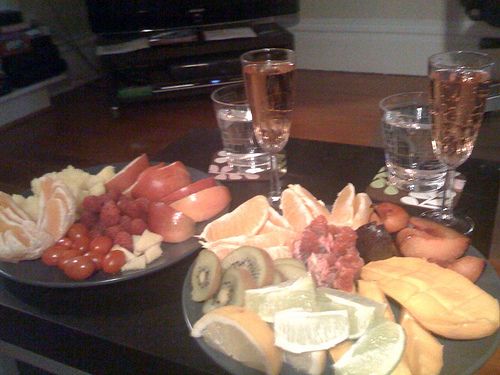How many plates are there? 2 